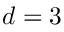Convert formula to latex. <formula><loc_0><loc_0><loc_500><loc_500>d = 3</formula> 